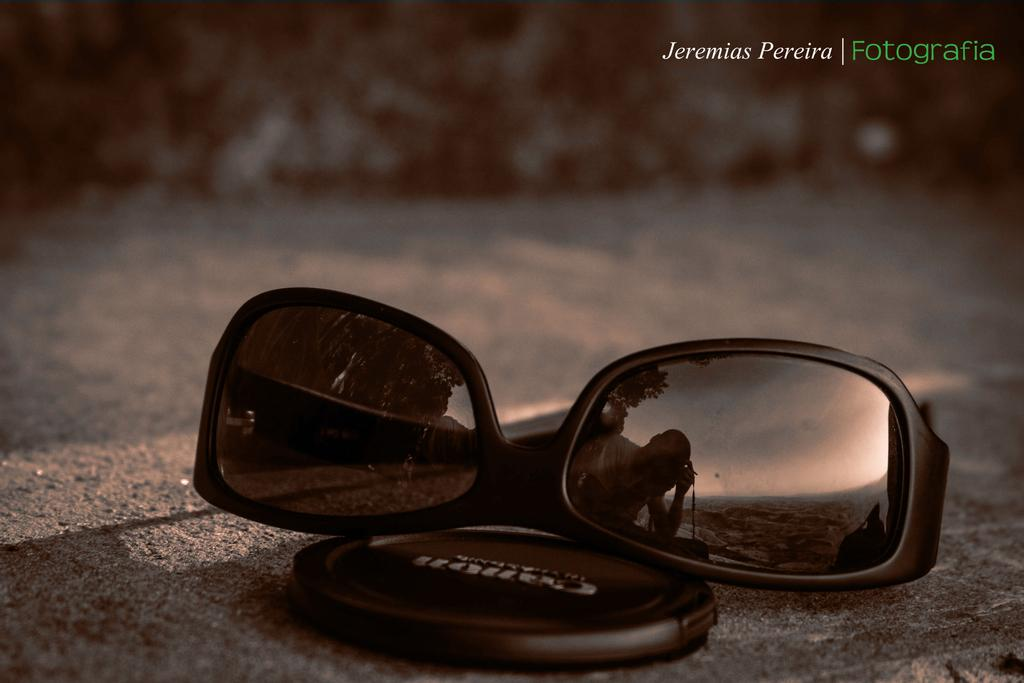What object is located in the foreground of the image? There are sunglasses in the foreground of the image. What other item can be seen on the floor in the image? There is a lens cap on the floor. What type of lettuce is being used as a paperweight in the image? There is no lettuce present in the image; it only features sunglasses and a lens cap. 